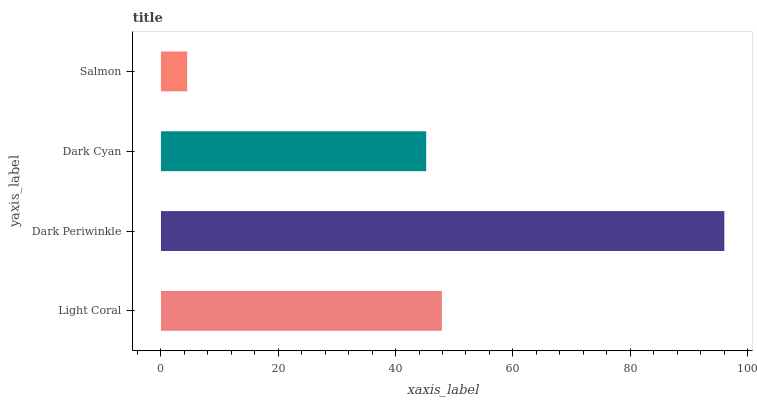Is Salmon the minimum?
Answer yes or no. Yes. Is Dark Periwinkle the maximum?
Answer yes or no. Yes. Is Dark Cyan the minimum?
Answer yes or no. No. Is Dark Cyan the maximum?
Answer yes or no. No. Is Dark Periwinkle greater than Dark Cyan?
Answer yes or no. Yes. Is Dark Cyan less than Dark Periwinkle?
Answer yes or no. Yes. Is Dark Cyan greater than Dark Periwinkle?
Answer yes or no. No. Is Dark Periwinkle less than Dark Cyan?
Answer yes or no. No. Is Light Coral the high median?
Answer yes or no. Yes. Is Dark Cyan the low median?
Answer yes or no. Yes. Is Salmon the high median?
Answer yes or no. No. Is Dark Periwinkle the low median?
Answer yes or no. No. 